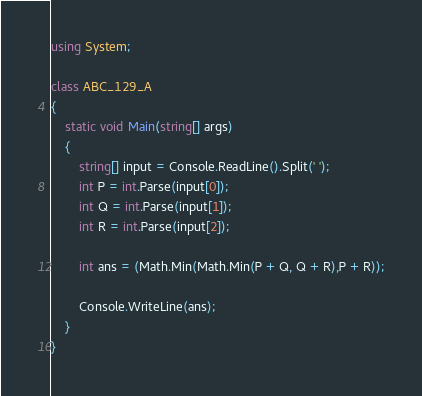<code> <loc_0><loc_0><loc_500><loc_500><_C#_>using System;

class ABC_129_A
{
    static void Main(string[] args)
    {
        string[] input = Console.ReadLine().Split(' ');
        int P = int.Parse(input[0]);
        int Q = int.Parse(input[1]);
        int R = int.Parse(input[2]);

        int ans = (Math.Min(Math.Min(P + Q, Q + R),P + R));

        Console.WriteLine(ans);
    }
}</code> 